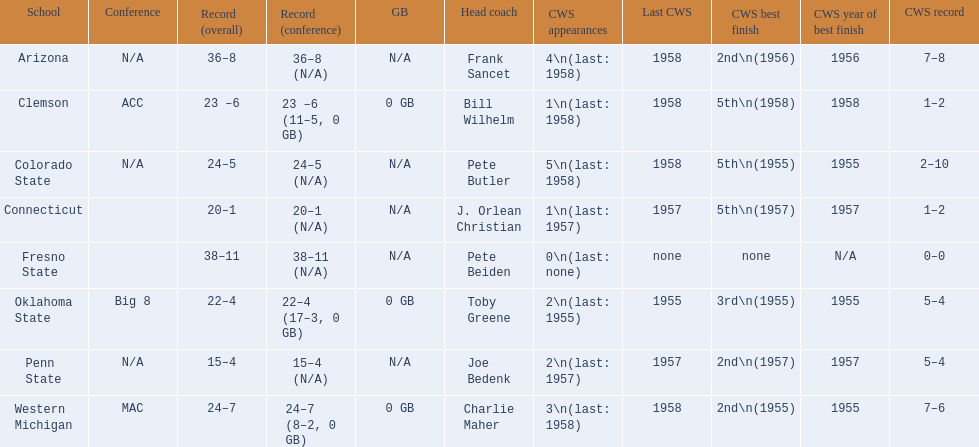What are all the schools? Arizona, Clemson, Colorado State, Connecticut, Fresno State, Oklahoma State, Penn State, Western Michigan. Which are clemson and western michigan? Clemson, Western Michigan. Of these, which has more cws appearances? Western Michigan. 